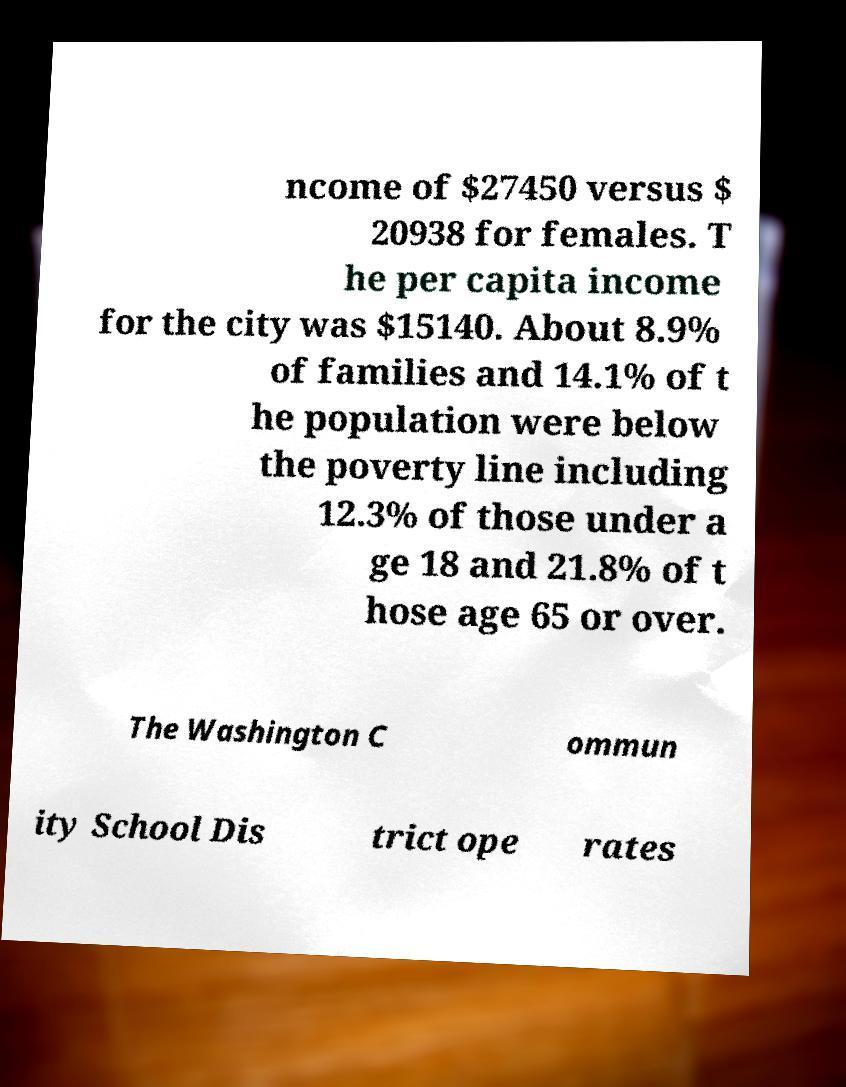Could you extract and type out the text from this image? ncome of $27450 versus $ 20938 for females. T he per capita income for the city was $15140. About 8.9% of families and 14.1% of t he population were below the poverty line including 12.3% of those under a ge 18 and 21.8% of t hose age 65 or over. The Washington C ommun ity School Dis trict ope rates 